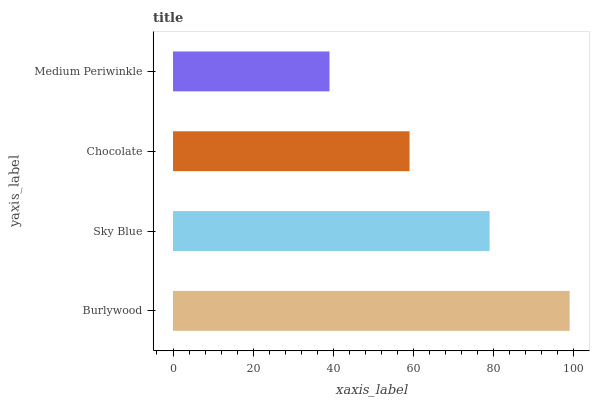Is Medium Periwinkle the minimum?
Answer yes or no. Yes. Is Burlywood the maximum?
Answer yes or no. Yes. Is Sky Blue the minimum?
Answer yes or no. No. Is Sky Blue the maximum?
Answer yes or no. No. Is Burlywood greater than Sky Blue?
Answer yes or no. Yes. Is Sky Blue less than Burlywood?
Answer yes or no. Yes. Is Sky Blue greater than Burlywood?
Answer yes or no. No. Is Burlywood less than Sky Blue?
Answer yes or no. No. Is Sky Blue the high median?
Answer yes or no. Yes. Is Chocolate the low median?
Answer yes or no. Yes. Is Chocolate the high median?
Answer yes or no. No. Is Medium Periwinkle the low median?
Answer yes or no. No. 